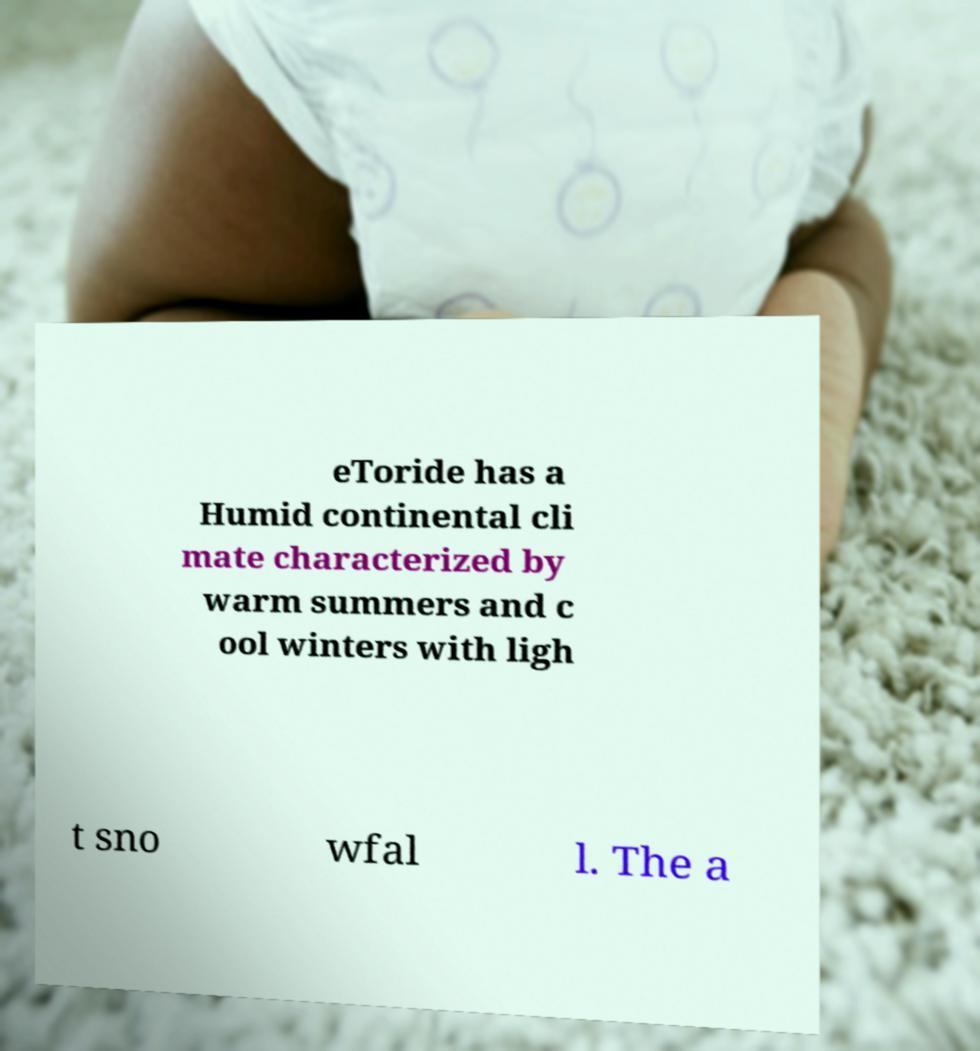For documentation purposes, I need the text within this image transcribed. Could you provide that? eToride has a Humid continental cli mate characterized by warm summers and c ool winters with ligh t sno wfal l. The a 